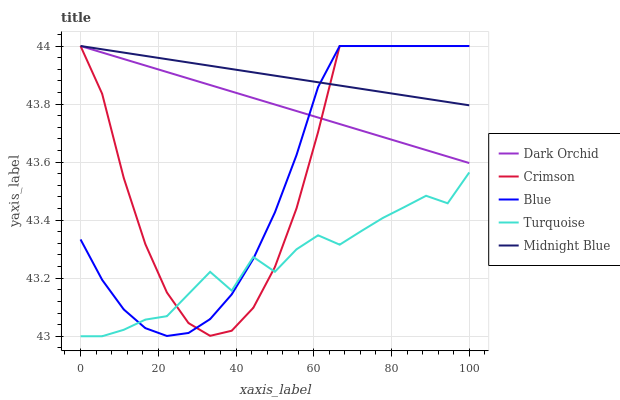Does Turquoise have the minimum area under the curve?
Answer yes or no. Yes. Does Midnight Blue have the maximum area under the curve?
Answer yes or no. Yes. Does Blue have the minimum area under the curve?
Answer yes or no. No. Does Blue have the maximum area under the curve?
Answer yes or no. No. Is Dark Orchid the smoothest?
Answer yes or no. Yes. Is Turquoise the roughest?
Answer yes or no. Yes. Is Blue the smoothest?
Answer yes or no. No. Is Blue the roughest?
Answer yes or no. No. Does Turquoise have the lowest value?
Answer yes or no. Yes. Does Blue have the lowest value?
Answer yes or no. No. Does Dark Orchid have the highest value?
Answer yes or no. Yes. Does Turquoise have the highest value?
Answer yes or no. No. Is Turquoise less than Midnight Blue?
Answer yes or no. Yes. Is Midnight Blue greater than Turquoise?
Answer yes or no. Yes. Does Blue intersect Midnight Blue?
Answer yes or no. Yes. Is Blue less than Midnight Blue?
Answer yes or no. No. Is Blue greater than Midnight Blue?
Answer yes or no. No. Does Turquoise intersect Midnight Blue?
Answer yes or no. No. 